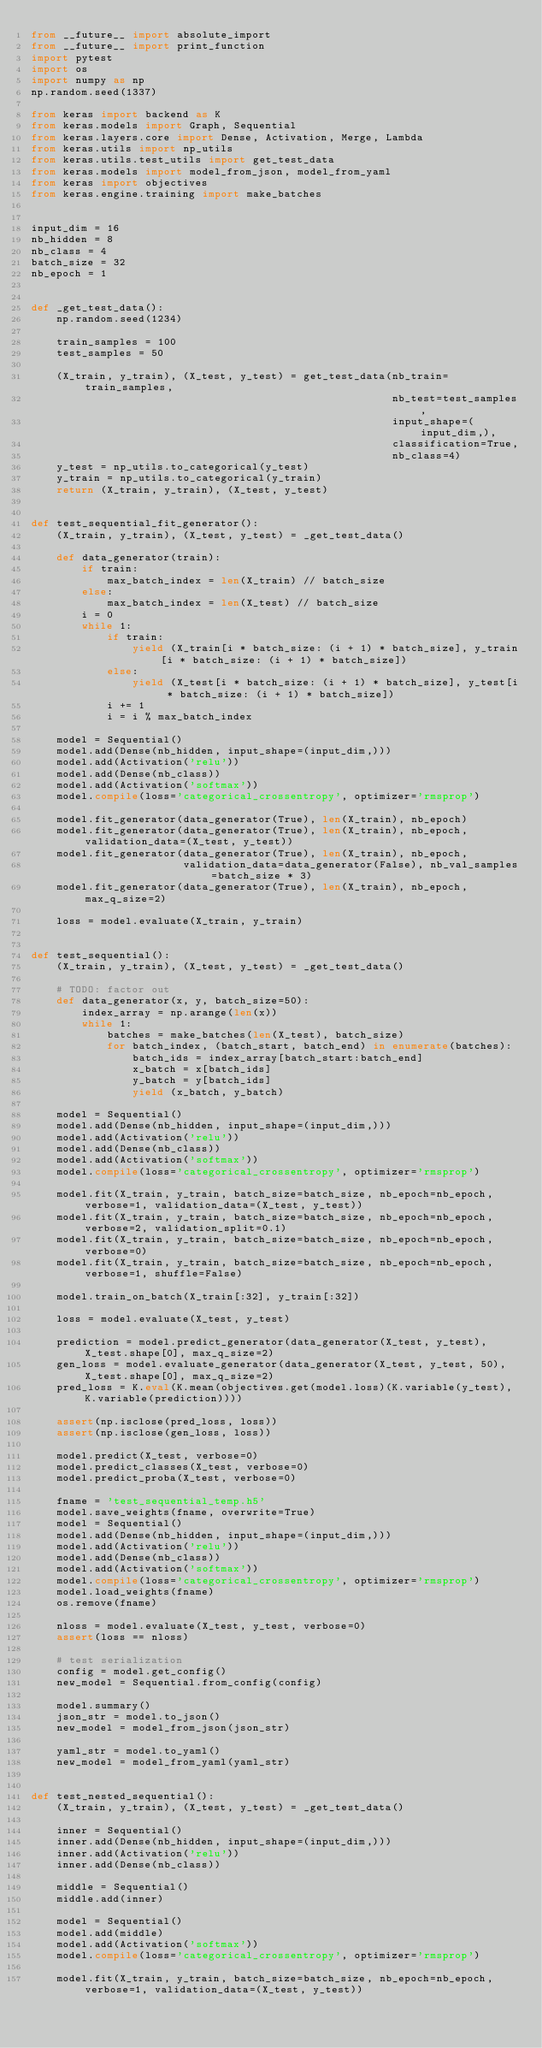<code> <loc_0><loc_0><loc_500><loc_500><_Python_>from __future__ import absolute_import
from __future__ import print_function
import pytest
import os
import numpy as np
np.random.seed(1337)

from keras import backend as K
from keras.models import Graph, Sequential
from keras.layers.core import Dense, Activation, Merge, Lambda
from keras.utils import np_utils
from keras.utils.test_utils import get_test_data
from keras.models import model_from_json, model_from_yaml
from keras import objectives
from keras.engine.training import make_batches


input_dim = 16
nb_hidden = 8
nb_class = 4
batch_size = 32
nb_epoch = 1


def _get_test_data():
    np.random.seed(1234)

    train_samples = 100
    test_samples = 50

    (X_train, y_train), (X_test, y_test) = get_test_data(nb_train=train_samples,
                                                         nb_test=test_samples,
                                                         input_shape=(input_dim,),
                                                         classification=True,
                                                         nb_class=4)
    y_test = np_utils.to_categorical(y_test)
    y_train = np_utils.to_categorical(y_train)
    return (X_train, y_train), (X_test, y_test)


def test_sequential_fit_generator():
    (X_train, y_train), (X_test, y_test) = _get_test_data()

    def data_generator(train):
        if train:
            max_batch_index = len(X_train) // batch_size
        else:
            max_batch_index = len(X_test) // batch_size
        i = 0
        while 1:
            if train:
                yield (X_train[i * batch_size: (i + 1) * batch_size], y_train[i * batch_size: (i + 1) * batch_size])
            else:
                yield (X_test[i * batch_size: (i + 1) * batch_size], y_test[i * batch_size: (i + 1) * batch_size])
            i += 1
            i = i % max_batch_index

    model = Sequential()
    model.add(Dense(nb_hidden, input_shape=(input_dim,)))
    model.add(Activation('relu'))
    model.add(Dense(nb_class))
    model.add(Activation('softmax'))
    model.compile(loss='categorical_crossentropy', optimizer='rmsprop')

    model.fit_generator(data_generator(True), len(X_train), nb_epoch)
    model.fit_generator(data_generator(True), len(X_train), nb_epoch, validation_data=(X_test, y_test))
    model.fit_generator(data_generator(True), len(X_train), nb_epoch,
                        validation_data=data_generator(False), nb_val_samples=batch_size * 3)
    model.fit_generator(data_generator(True), len(X_train), nb_epoch, max_q_size=2)

    loss = model.evaluate(X_train, y_train)


def test_sequential():
    (X_train, y_train), (X_test, y_test) = _get_test_data()

    # TODO: factor out
    def data_generator(x, y, batch_size=50):
        index_array = np.arange(len(x))
        while 1:
            batches = make_batches(len(X_test), batch_size)
            for batch_index, (batch_start, batch_end) in enumerate(batches):
                batch_ids = index_array[batch_start:batch_end]
                x_batch = x[batch_ids]
                y_batch = y[batch_ids]
                yield (x_batch, y_batch)

    model = Sequential()
    model.add(Dense(nb_hidden, input_shape=(input_dim,)))
    model.add(Activation('relu'))
    model.add(Dense(nb_class))
    model.add(Activation('softmax'))
    model.compile(loss='categorical_crossentropy', optimizer='rmsprop')

    model.fit(X_train, y_train, batch_size=batch_size, nb_epoch=nb_epoch, verbose=1, validation_data=(X_test, y_test))
    model.fit(X_train, y_train, batch_size=batch_size, nb_epoch=nb_epoch, verbose=2, validation_split=0.1)
    model.fit(X_train, y_train, batch_size=batch_size, nb_epoch=nb_epoch, verbose=0)
    model.fit(X_train, y_train, batch_size=batch_size, nb_epoch=nb_epoch, verbose=1, shuffle=False)

    model.train_on_batch(X_train[:32], y_train[:32])

    loss = model.evaluate(X_test, y_test)

    prediction = model.predict_generator(data_generator(X_test, y_test), X_test.shape[0], max_q_size=2)
    gen_loss = model.evaluate_generator(data_generator(X_test, y_test, 50), X_test.shape[0], max_q_size=2)
    pred_loss = K.eval(K.mean(objectives.get(model.loss)(K.variable(y_test), K.variable(prediction))))

    assert(np.isclose(pred_loss, loss))
    assert(np.isclose(gen_loss, loss))

    model.predict(X_test, verbose=0)
    model.predict_classes(X_test, verbose=0)
    model.predict_proba(X_test, verbose=0)

    fname = 'test_sequential_temp.h5'
    model.save_weights(fname, overwrite=True)
    model = Sequential()
    model.add(Dense(nb_hidden, input_shape=(input_dim,)))
    model.add(Activation('relu'))
    model.add(Dense(nb_class))
    model.add(Activation('softmax'))
    model.compile(loss='categorical_crossentropy', optimizer='rmsprop')
    model.load_weights(fname)
    os.remove(fname)

    nloss = model.evaluate(X_test, y_test, verbose=0)
    assert(loss == nloss)

    # test serialization
    config = model.get_config()
    new_model = Sequential.from_config(config)

    model.summary()
    json_str = model.to_json()
    new_model = model_from_json(json_str)

    yaml_str = model.to_yaml()
    new_model = model_from_yaml(yaml_str)


def test_nested_sequential():
    (X_train, y_train), (X_test, y_test) = _get_test_data()

    inner = Sequential()
    inner.add(Dense(nb_hidden, input_shape=(input_dim,)))
    inner.add(Activation('relu'))
    inner.add(Dense(nb_class))

    middle = Sequential()
    middle.add(inner)

    model = Sequential()
    model.add(middle)
    model.add(Activation('softmax'))
    model.compile(loss='categorical_crossentropy', optimizer='rmsprop')

    model.fit(X_train, y_train, batch_size=batch_size, nb_epoch=nb_epoch, verbose=1, validation_data=(X_test, y_test))</code> 